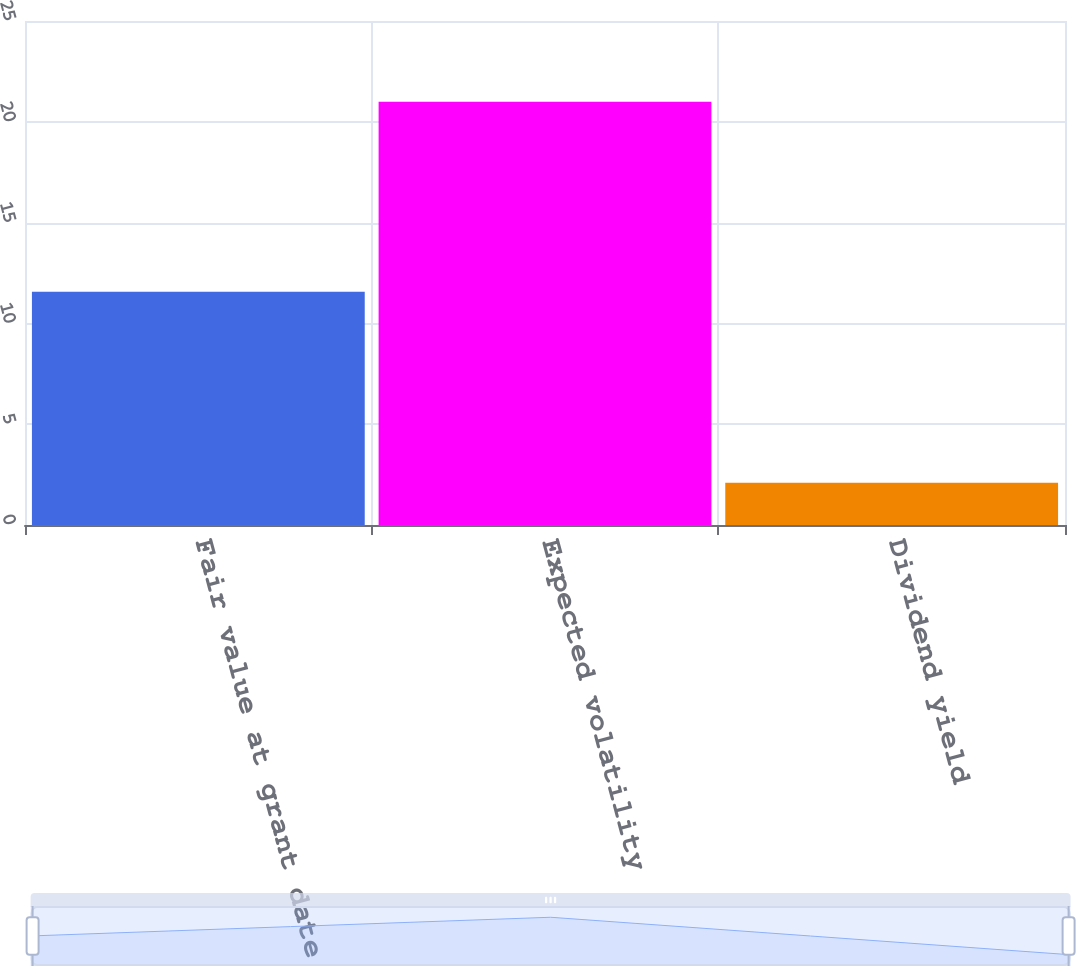Convert chart. <chart><loc_0><loc_0><loc_500><loc_500><bar_chart><fcel>Fair value at grant date<fcel>Expected volatility<fcel>Dividend yield<nl><fcel>11.57<fcel>21<fcel>2.1<nl></chart> 